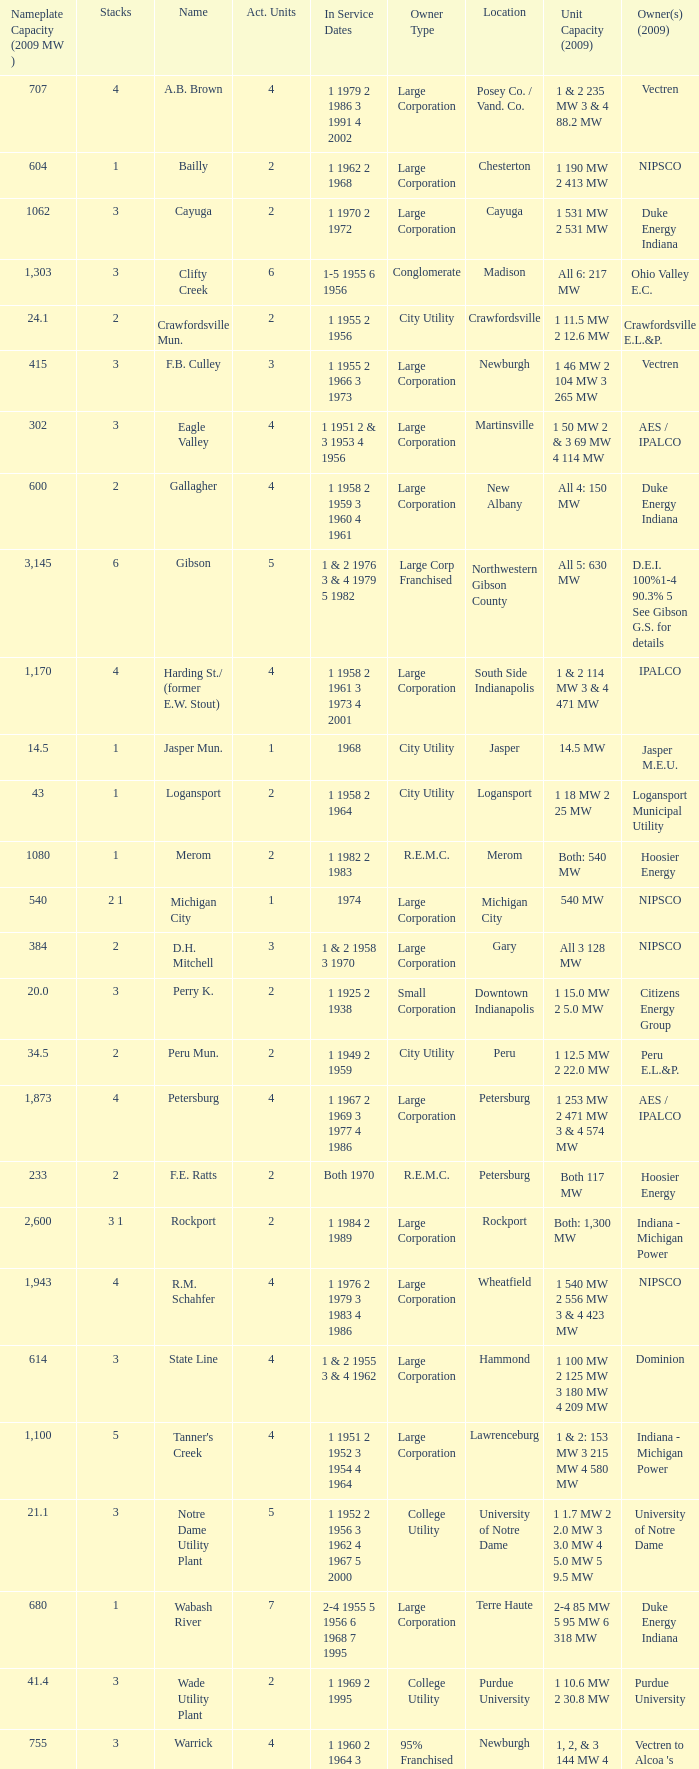What are the stacks for 1969 and 1995? 3.0. 